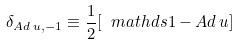Convert formula to latex. <formula><loc_0><loc_0><loc_500><loc_500>\delta _ { A d \, u , - 1 } \equiv \frac { 1 } { 2 } [ \ m a t h d s { 1 } - A d \, u ]</formula> 